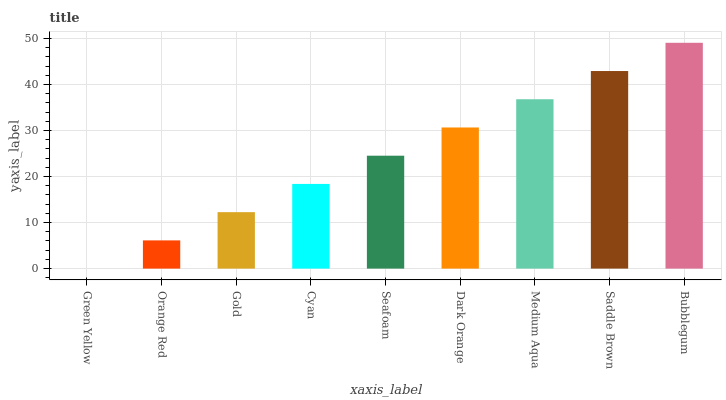Is Green Yellow the minimum?
Answer yes or no. Yes. Is Bubblegum the maximum?
Answer yes or no. Yes. Is Orange Red the minimum?
Answer yes or no. No. Is Orange Red the maximum?
Answer yes or no. No. Is Orange Red greater than Green Yellow?
Answer yes or no. Yes. Is Green Yellow less than Orange Red?
Answer yes or no. Yes. Is Green Yellow greater than Orange Red?
Answer yes or no. No. Is Orange Red less than Green Yellow?
Answer yes or no. No. Is Seafoam the high median?
Answer yes or no. Yes. Is Seafoam the low median?
Answer yes or no. Yes. Is Saddle Brown the high median?
Answer yes or no. No. Is Bubblegum the low median?
Answer yes or no. No. 